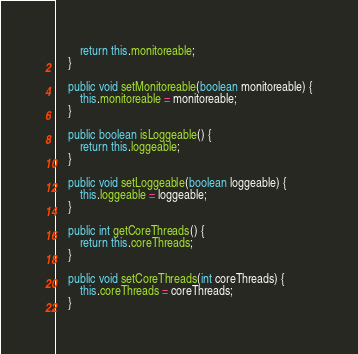Convert code to text. <code><loc_0><loc_0><loc_500><loc_500><_Java_>        return this.monitoreable;
    }

    public void setMonitoreable(boolean monitoreable) {
        this.monitoreable = monitoreable;
    }

    public boolean isLoggeable() {
        return this.loggeable;
    }

    public void setLoggeable(boolean loggeable) {
        this.loggeable = loggeable;
    }

    public int getCoreThreads() {
        return this.coreThreads;
    }

    public void setCoreThreads(int coreThreads) {
        this.coreThreads = coreThreads;
    }
</code> 